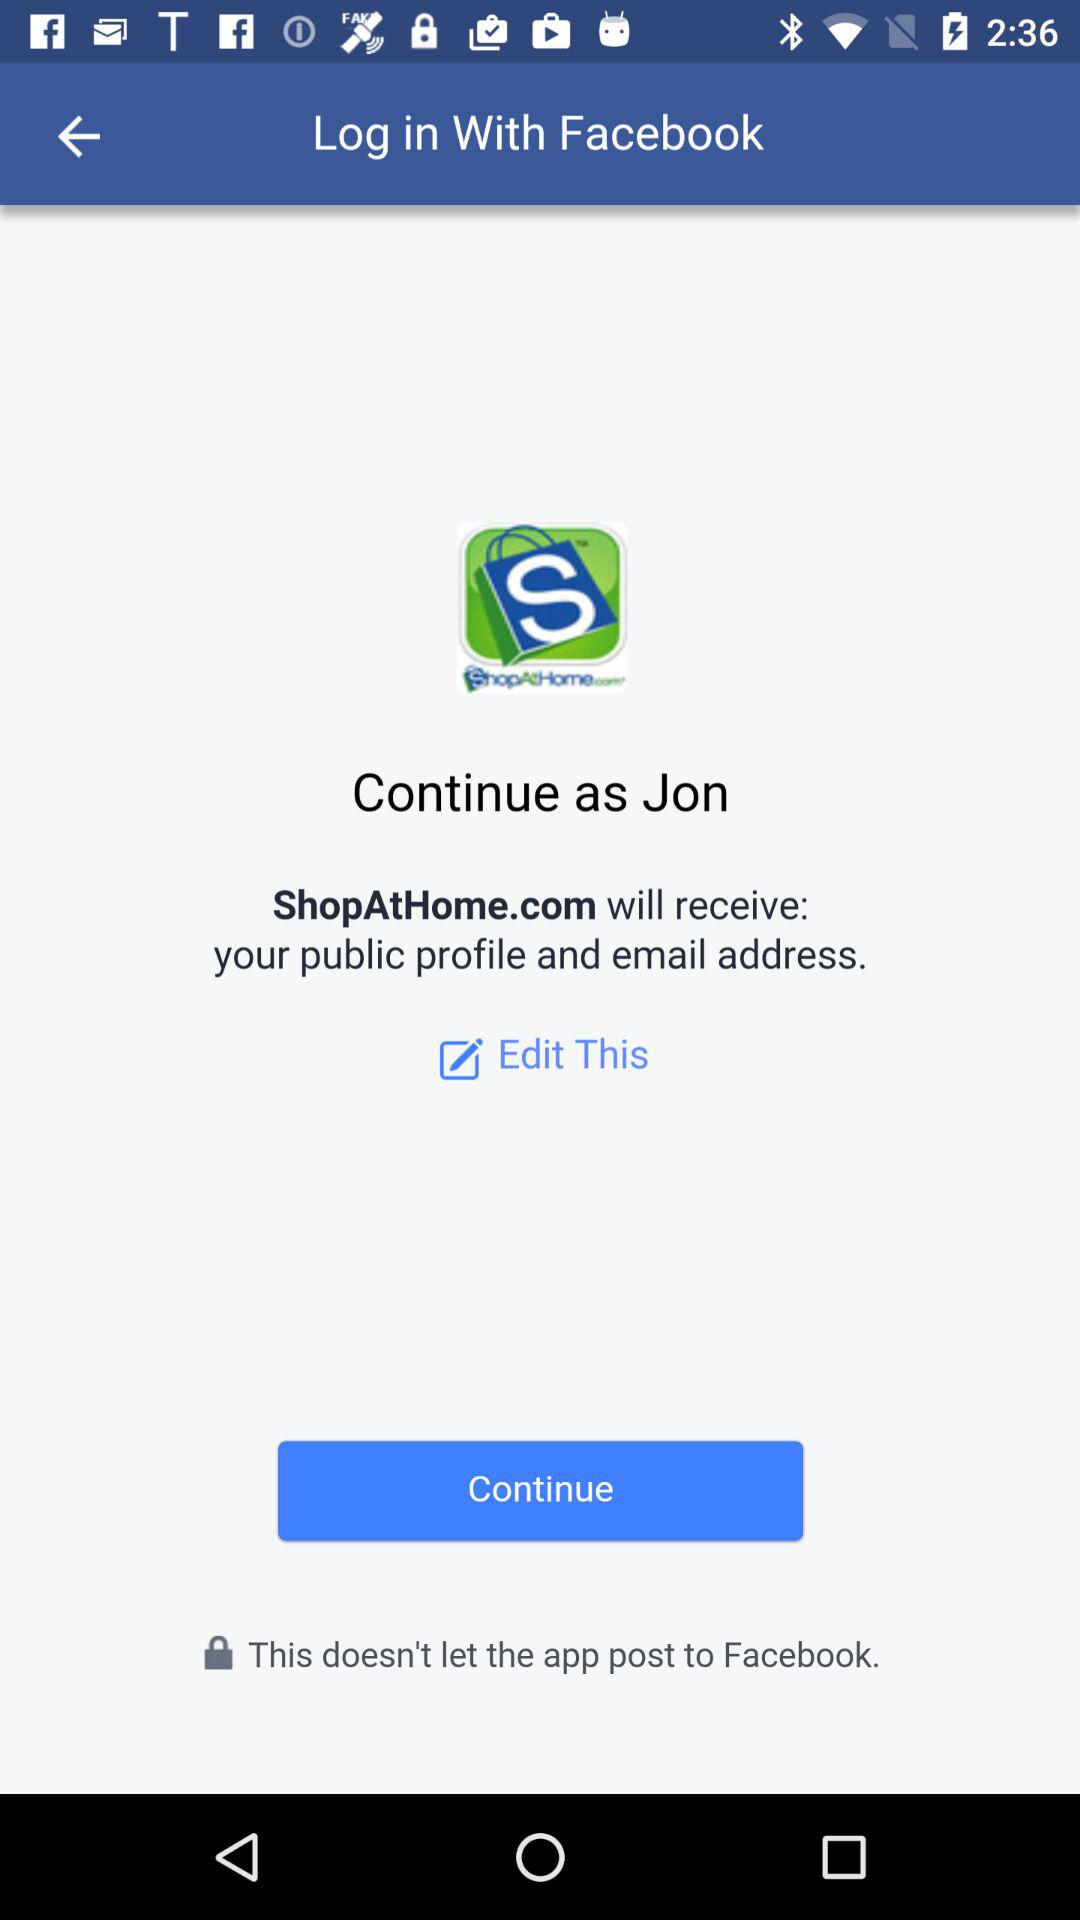What application is asking for permission? The application asking for permission is "ShopAtHome.com". 